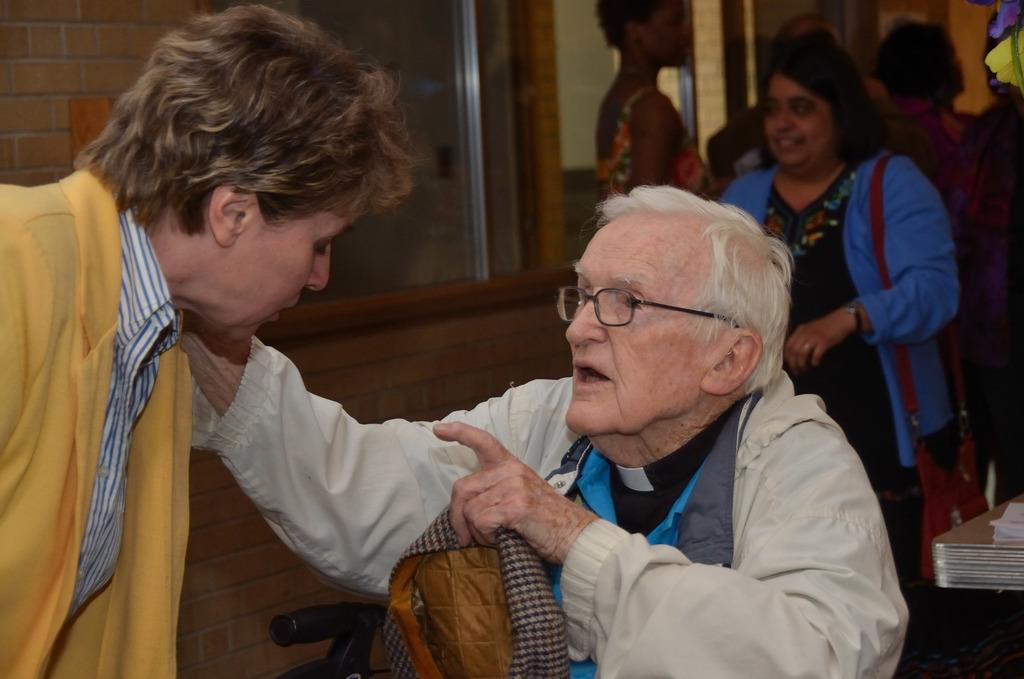What are the people in the image doing? The people in the image are standing on the floor. Can you describe the position of the person in the chair? There is a person sitting on a chair in the image. What is the person sitting on the chair holding? The person sitting on the chair is holding a bag. What can be seen on the wall in the image? There is a wall with a window in the image. What type of unit is being used to cook the fowl in the image? There is no unit or fowl present in the image; it only features people standing and sitting. 